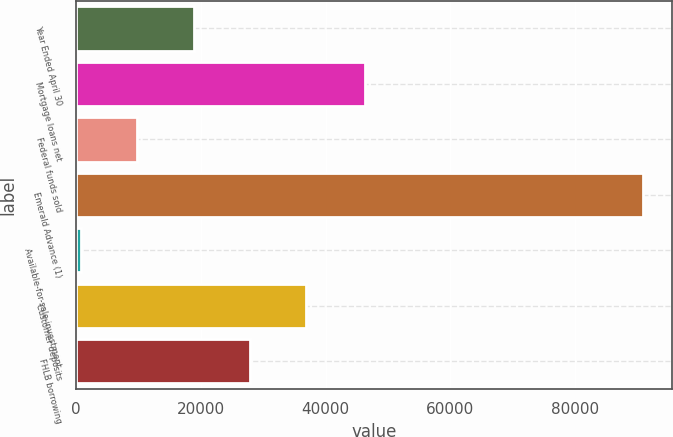Convert chart to OTSL. <chart><loc_0><loc_0><loc_500><loc_500><bar_chart><fcel>Year Ended April 30<fcel>Mortgage loans net<fcel>Federal funds sold<fcel>Emerald Advance (1)<fcel>Available-for-sale investment<fcel>Customer deposits<fcel>FHLB borrowing<nl><fcel>18836.6<fcel>46396<fcel>9813.8<fcel>91019<fcel>791<fcel>36882.2<fcel>27859.4<nl></chart> 